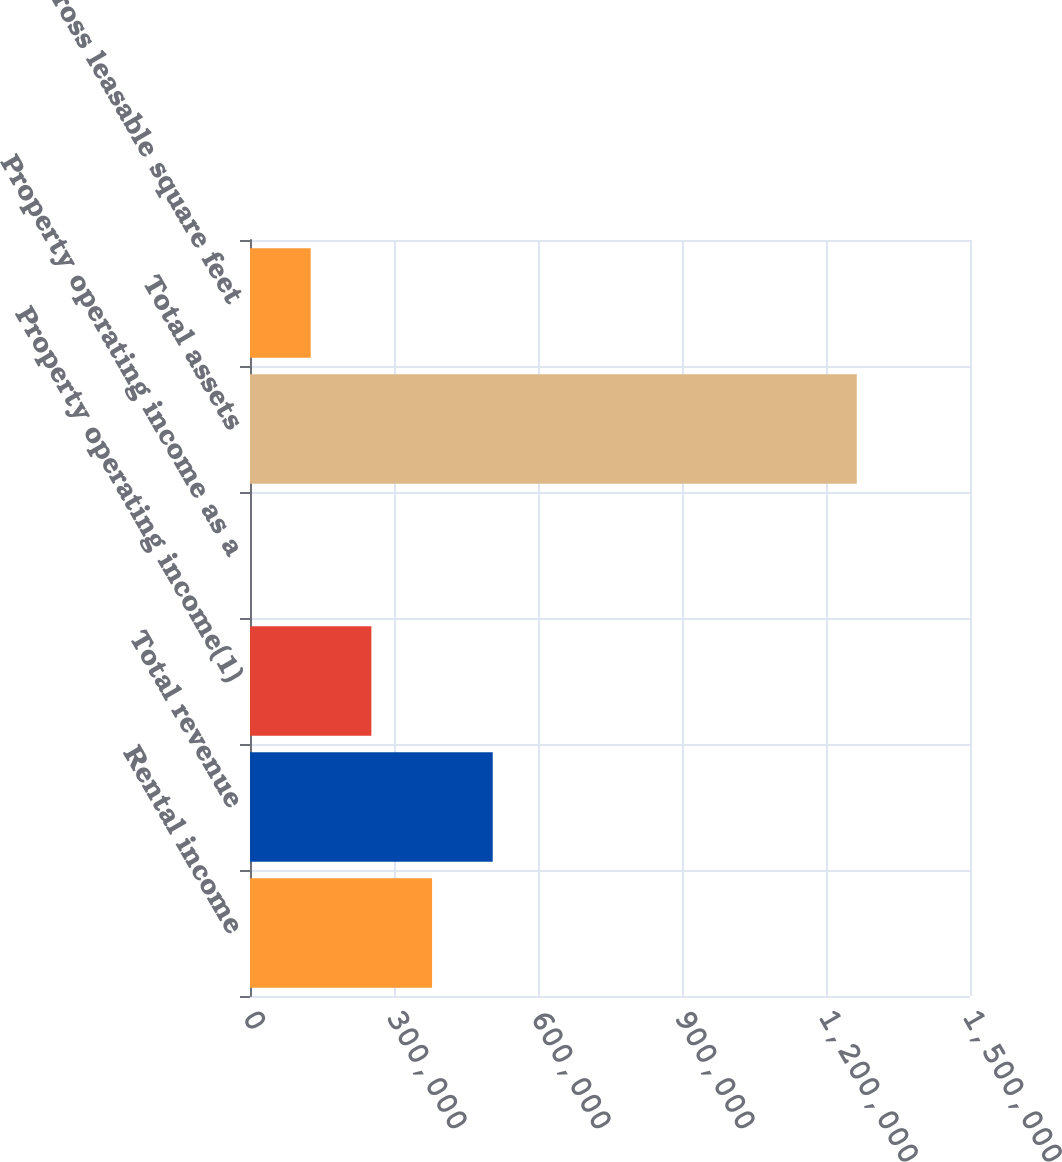Convert chart to OTSL. <chart><loc_0><loc_0><loc_500><loc_500><bar_chart><fcel>Rental income<fcel>Total revenue<fcel>Property operating income(1)<fcel>Property operating income as a<fcel>Total assets<fcel>Gross leasable square feet<nl><fcel>379289<fcel>505696<fcel>252882<fcel>69.3<fcel>1.26414e+06<fcel>126476<nl></chart> 